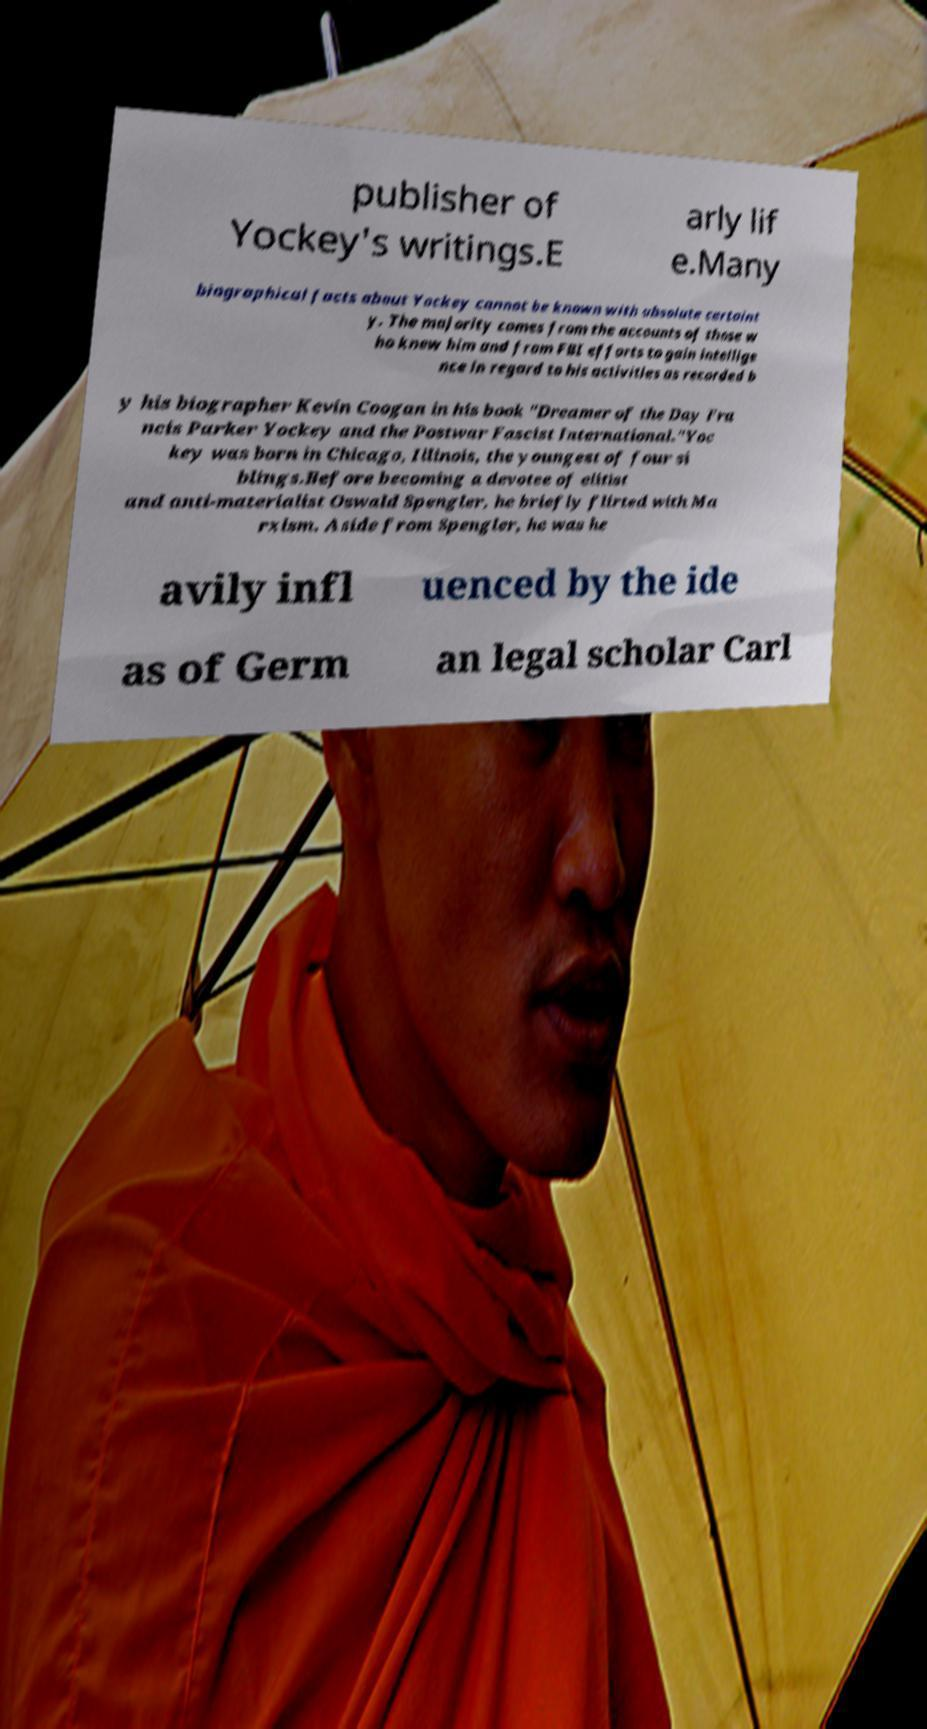For documentation purposes, I need the text within this image transcribed. Could you provide that? publisher of Yockey's writings.E arly lif e.Many biographical facts about Yockey cannot be known with absolute certaint y. The majority comes from the accounts of those w ho knew him and from FBI efforts to gain intellige nce in regard to his activities as recorded b y his biographer Kevin Coogan in his book "Dreamer of the Day Fra ncis Parker Yockey and the Postwar Fascist International."Yoc key was born in Chicago, Illinois, the youngest of four si blings.Before becoming a devotee of elitist and anti-materialist Oswald Spengler, he briefly flirted with Ma rxism. Aside from Spengler, he was he avily infl uenced by the ide as of Germ an legal scholar Carl 